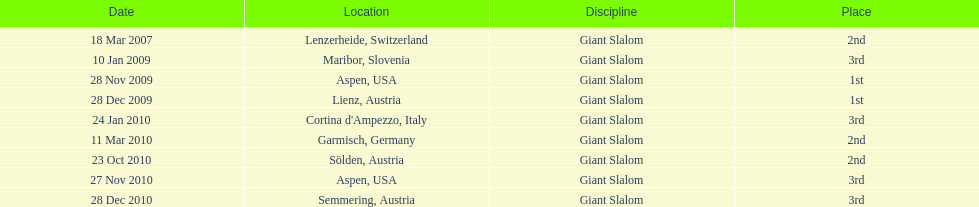Parse the table in full. {'header': ['Date', 'Location', 'Discipline', 'Place'], 'rows': [['18 Mar 2007', 'Lenzerheide, Switzerland', 'Giant Slalom', '2nd'], ['10 Jan 2009', 'Maribor, Slovenia', 'Giant Slalom', '3rd'], ['28 Nov 2009', 'Aspen, USA', 'Giant Slalom', '1st'], ['28 Dec 2009', 'Lienz, Austria', 'Giant Slalom', '1st'], ['24 Jan 2010', "Cortina d'Ampezzo, Italy", 'Giant Slalom', '3rd'], ['11 Mar 2010', 'Garmisch, Germany', 'Giant Slalom', '2nd'], ['23 Oct 2010', 'Sölden, Austria', 'Giant Slalom', '2nd'], ['27 Nov 2010', 'Aspen, USA', 'Giant Slalom', '3rd'], ['28 Dec 2010', 'Semmering, Austria', 'Giant Slalom', '3rd']]} Aspen and lienz in 2009 are the only races where this racer got what position? 1st. 